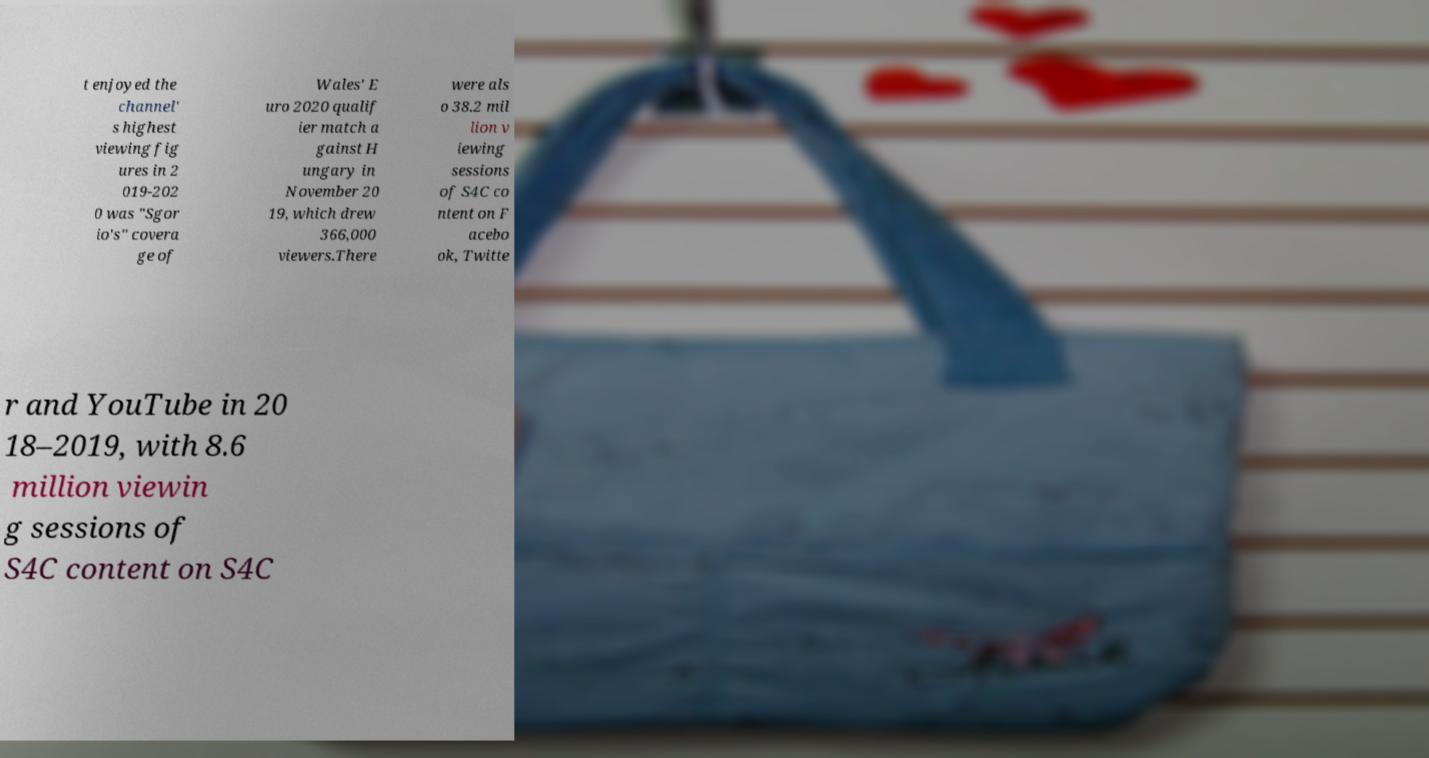For documentation purposes, I need the text within this image transcribed. Could you provide that? t enjoyed the channel' s highest viewing fig ures in 2 019-202 0 was "Sgor io's" covera ge of Wales' E uro 2020 qualif ier match a gainst H ungary in November 20 19, which drew 366,000 viewers.There were als o 38.2 mil lion v iewing sessions of S4C co ntent on F acebo ok, Twitte r and YouTube in 20 18–2019, with 8.6 million viewin g sessions of S4C content on S4C 